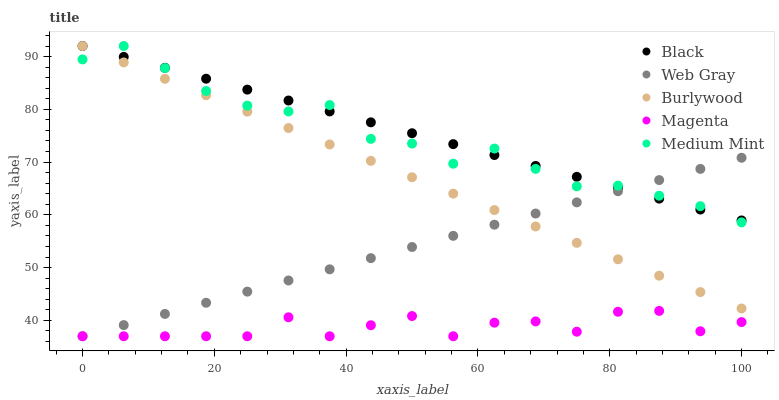Does Magenta have the minimum area under the curve?
Answer yes or no. Yes. Does Black have the maximum area under the curve?
Answer yes or no. Yes. Does Medium Mint have the minimum area under the curve?
Answer yes or no. No. Does Medium Mint have the maximum area under the curve?
Answer yes or no. No. Is Web Gray the smoothest?
Answer yes or no. Yes. Is Magenta the roughest?
Answer yes or no. Yes. Is Medium Mint the smoothest?
Answer yes or no. No. Is Medium Mint the roughest?
Answer yes or no. No. Does Magenta have the lowest value?
Answer yes or no. Yes. Does Medium Mint have the lowest value?
Answer yes or no. No. Does Black have the highest value?
Answer yes or no. Yes. Does Magenta have the highest value?
Answer yes or no. No. Is Magenta less than Burlywood?
Answer yes or no. Yes. Is Medium Mint greater than Magenta?
Answer yes or no. Yes. Does Medium Mint intersect Web Gray?
Answer yes or no. Yes. Is Medium Mint less than Web Gray?
Answer yes or no. No. Is Medium Mint greater than Web Gray?
Answer yes or no. No. Does Magenta intersect Burlywood?
Answer yes or no. No. 